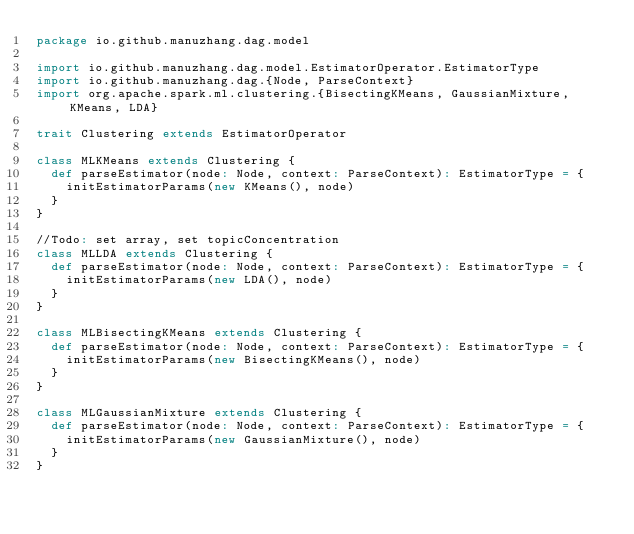Convert code to text. <code><loc_0><loc_0><loc_500><loc_500><_Scala_>package io.github.manuzhang.dag.model

import io.github.manuzhang.dag.model.EstimatorOperator.EstimatorType
import io.github.manuzhang.dag.{Node, ParseContext}
import org.apache.spark.ml.clustering.{BisectingKMeans, GaussianMixture, KMeans, LDA}

trait Clustering extends EstimatorOperator

class MLKMeans extends Clustering {
  def parseEstimator(node: Node, context: ParseContext): EstimatorType = {
    initEstimatorParams(new KMeans(), node)
  }
}

//Todo: set array, set topicConcentration
class MLLDA extends Clustering {
  def parseEstimator(node: Node, context: ParseContext): EstimatorType = {
    initEstimatorParams(new LDA(), node)
  }
}

class MLBisectingKMeans extends Clustering {
  def parseEstimator(node: Node, context: ParseContext): EstimatorType = {
    initEstimatorParams(new BisectingKMeans(), node)
  }
}

class MLGaussianMixture extends Clustering {
  def parseEstimator(node: Node, context: ParseContext): EstimatorType = {
    initEstimatorParams(new GaussianMixture(), node)
  }
}
</code> 